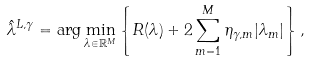Convert formula to latex. <formula><loc_0><loc_0><loc_500><loc_500>\hat { \lambda } ^ { L , \gamma } = \arg \min _ { \lambda \in \mathbb { R } ^ { M } } \left \{ R ( \lambda ) + 2 \sum _ { m = 1 } ^ { M } \eta _ { \gamma , m } | \lambda _ { m } | \right \} ,</formula> 